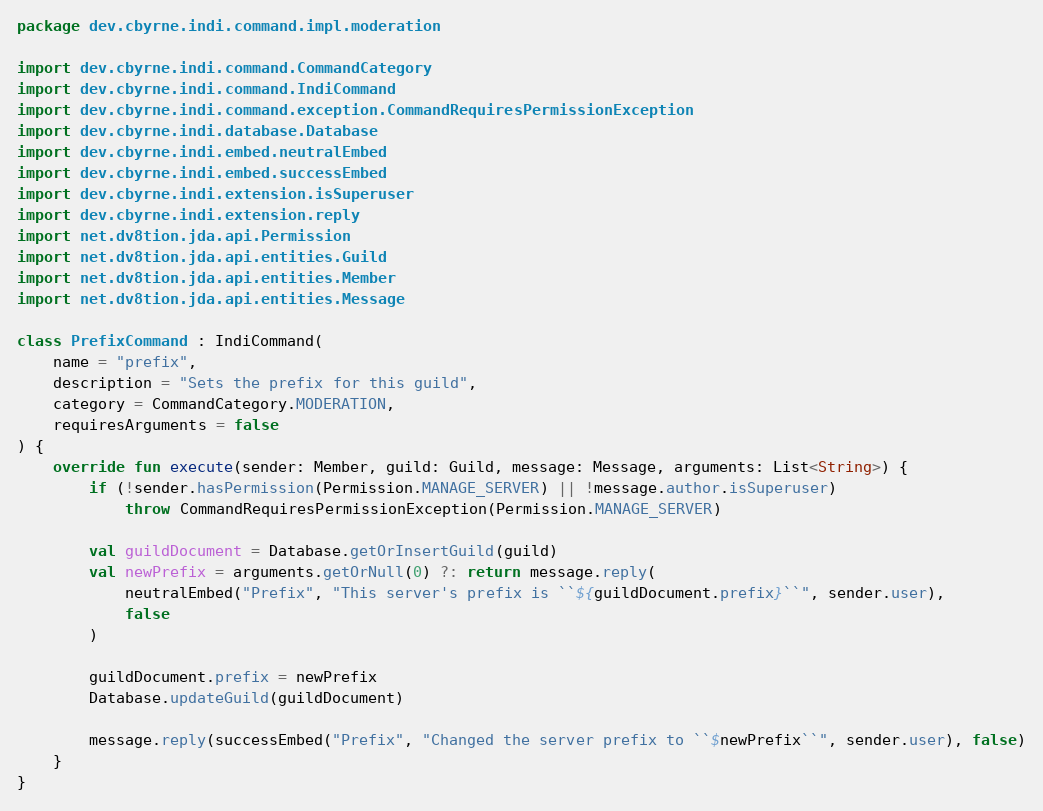Convert code to text. <code><loc_0><loc_0><loc_500><loc_500><_Kotlin_>package dev.cbyrne.indi.command.impl.moderation

import dev.cbyrne.indi.command.CommandCategory
import dev.cbyrne.indi.command.IndiCommand
import dev.cbyrne.indi.command.exception.CommandRequiresPermissionException
import dev.cbyrne.indi.database.Database
import dev.cbyrne.indi.embed.neutralEmbed
import dev.cbyrne.indi.embed.successEmbed
import dev.cbyrne.indi.extension.isSuperuser
import dev.cbyrne.indi.extension.reply
import net.dv8tion.jda.api.Permission
import net.dv8tion.jda.api.entities.Guild
import net.dv8tion.jda.api.entities.Member
import net.dv8tion.jda.api.entities.Message

class PrefixCommand : IndiCommand(
    name = "prefix",
    description = "Sets the prefix for this guild",
    category = CommandCategory.MODERATION,
    requiresArguments = false
) {
    override fun execute(sender: Member, guild: Guild, message: Message, arguments: List<String>) {
        if (!sender.hasPermission(Permission.MANAGE_SERVER) || !message.author.isSuperuser)
            throw CommandRequiresPermissionException(Permission.MANAGE_SERVER)

        val guildDocument = Database.getOrInsertGuild(guild)
        val newPrefix = arguments.getOrNull(0) ?: return message.reply(
            neutralEmbed("Prefix", "This server's prefix is ``${guildDocument.prefix}``", sender.user),
            false
        )

        guildDocument.prefix = newPrefix
        Database.updateGuild(guildDocument)

        message.reply(successEmbed("Prefix", "Changed the server prefix to ``$newPrefix``", sender.user), false)
    }
}</code> 